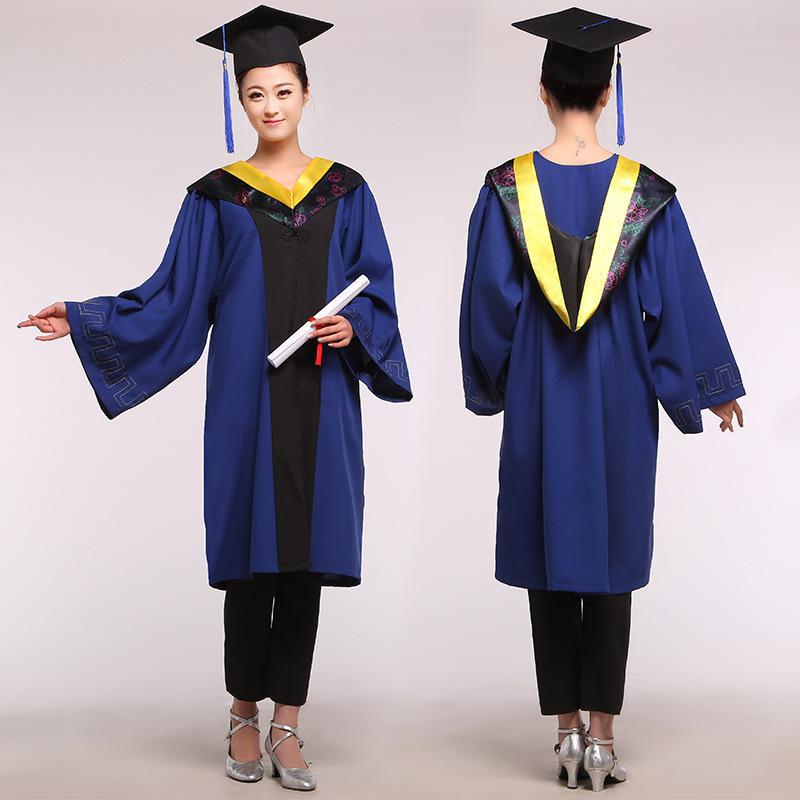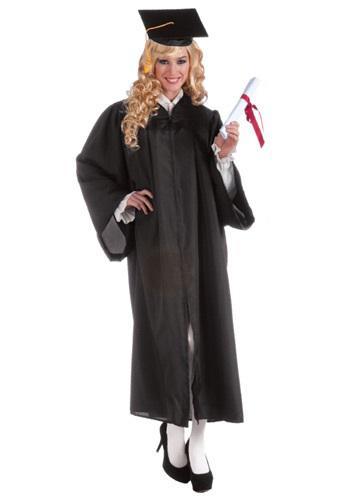The first image is the image on the left, the second image is the image on the right. Considering the images on both sides, is "There is exactly one woman not holding a diploma in the image on the right" valid? Answer yes or no. No. The first image is the image on the left, the second image is the image on the right. Considering the images on both sides, is "In one image a graduation gown worn by a woman is black and red." valid? Answer yes or no. No. 